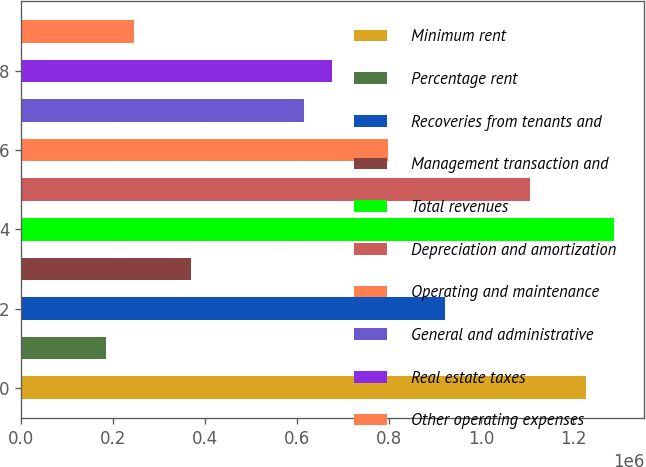Convert chart. <chart><loc_0><loc_0><loc_500><loc_500><bar_chart><fcel>Minimum rent<fcel>Percentage rent<fcel>Recoveries from tenants and<fcel>Management transaction and<fcel>Total revenues<fcel>Depreciation and amortization<fcel>Operating and maintenance<fcel>General and administrative<fcel>Real estate taxes<fcel>Other operating expenses<nl><fcel>1.22874e+06<fcel>184312<fcel>921556<fcel>368623<fcel>1.29018e+06<fcel>1.10587e+06<fcel>798682<fcel>614371<fcel>675808<fcel>245749<nl></chart> 